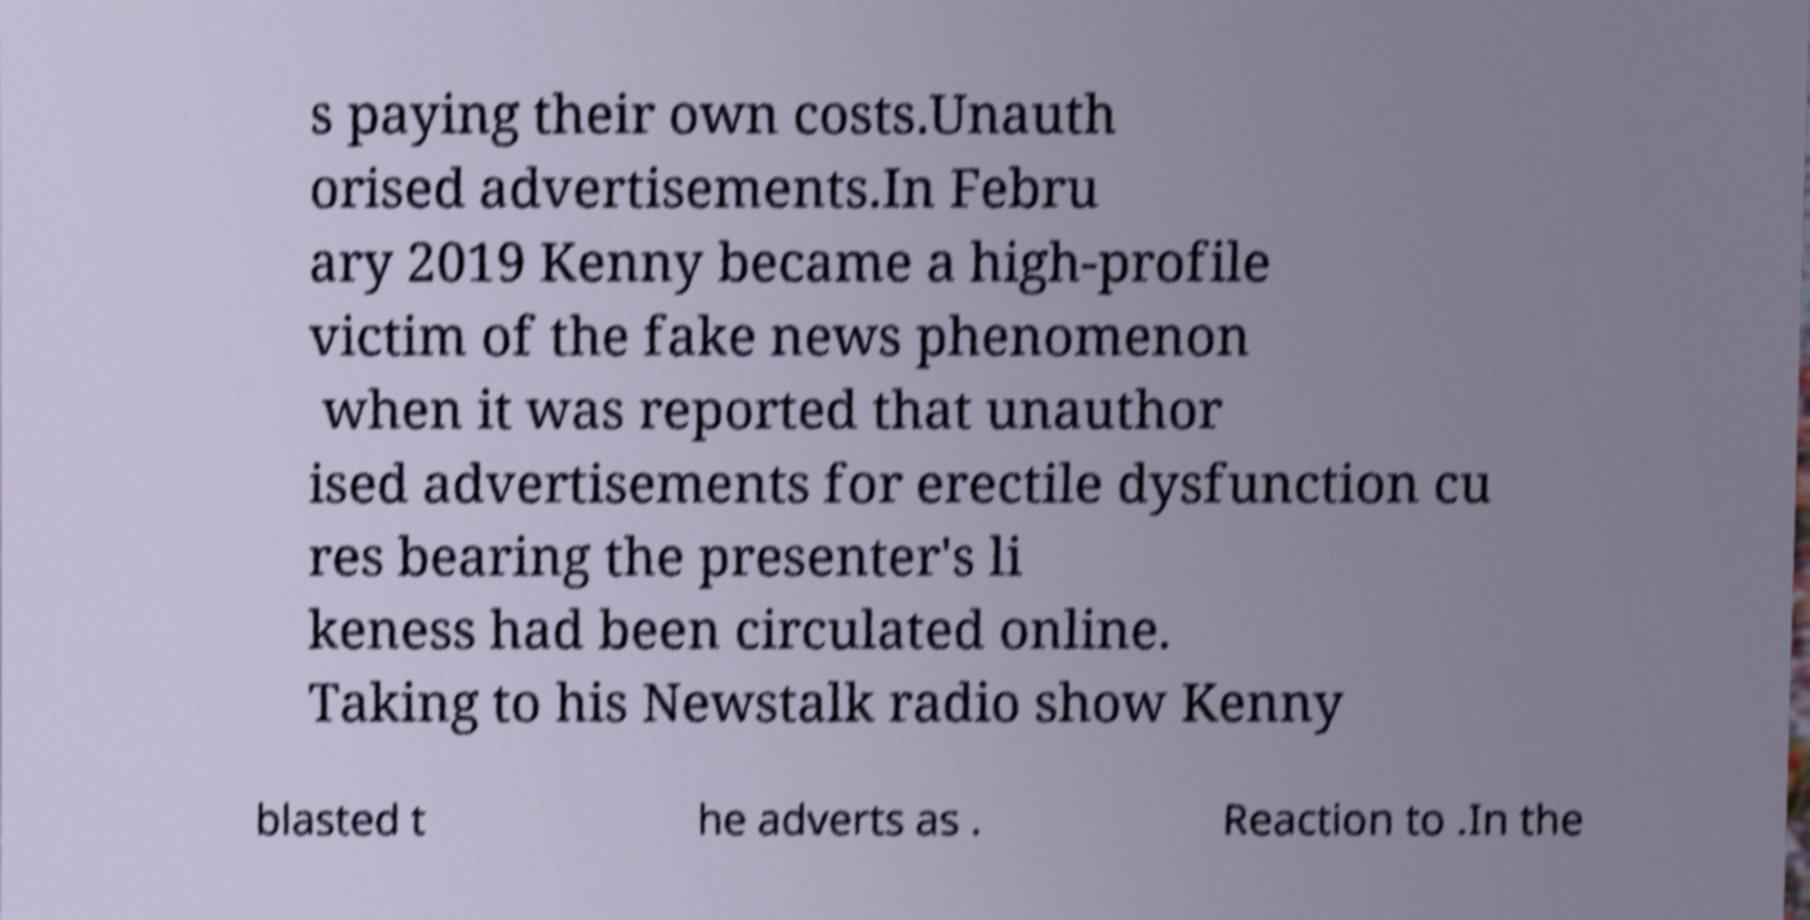For documentation purposes, I need the text within this image transcribed. Could you provide that? s paying their own costs.Unauth orised advertisements.In Febru ary 2019 Kenny became a high-profile victim of the fake news phenomenon when it was reported that unauthor ised advertisements for erectile dysfunction cu res bearing the presenter's li keness had been circulated online. Taking to his Newstalk radio show Kenny blasted t he adverts as . Reaction to .In the 